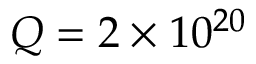Convert formula to latex. <formula><loc_0><loc_0><loc_500><loc_500>Q = 2 \times 1 0 ^ { 2 0 }</formula> 